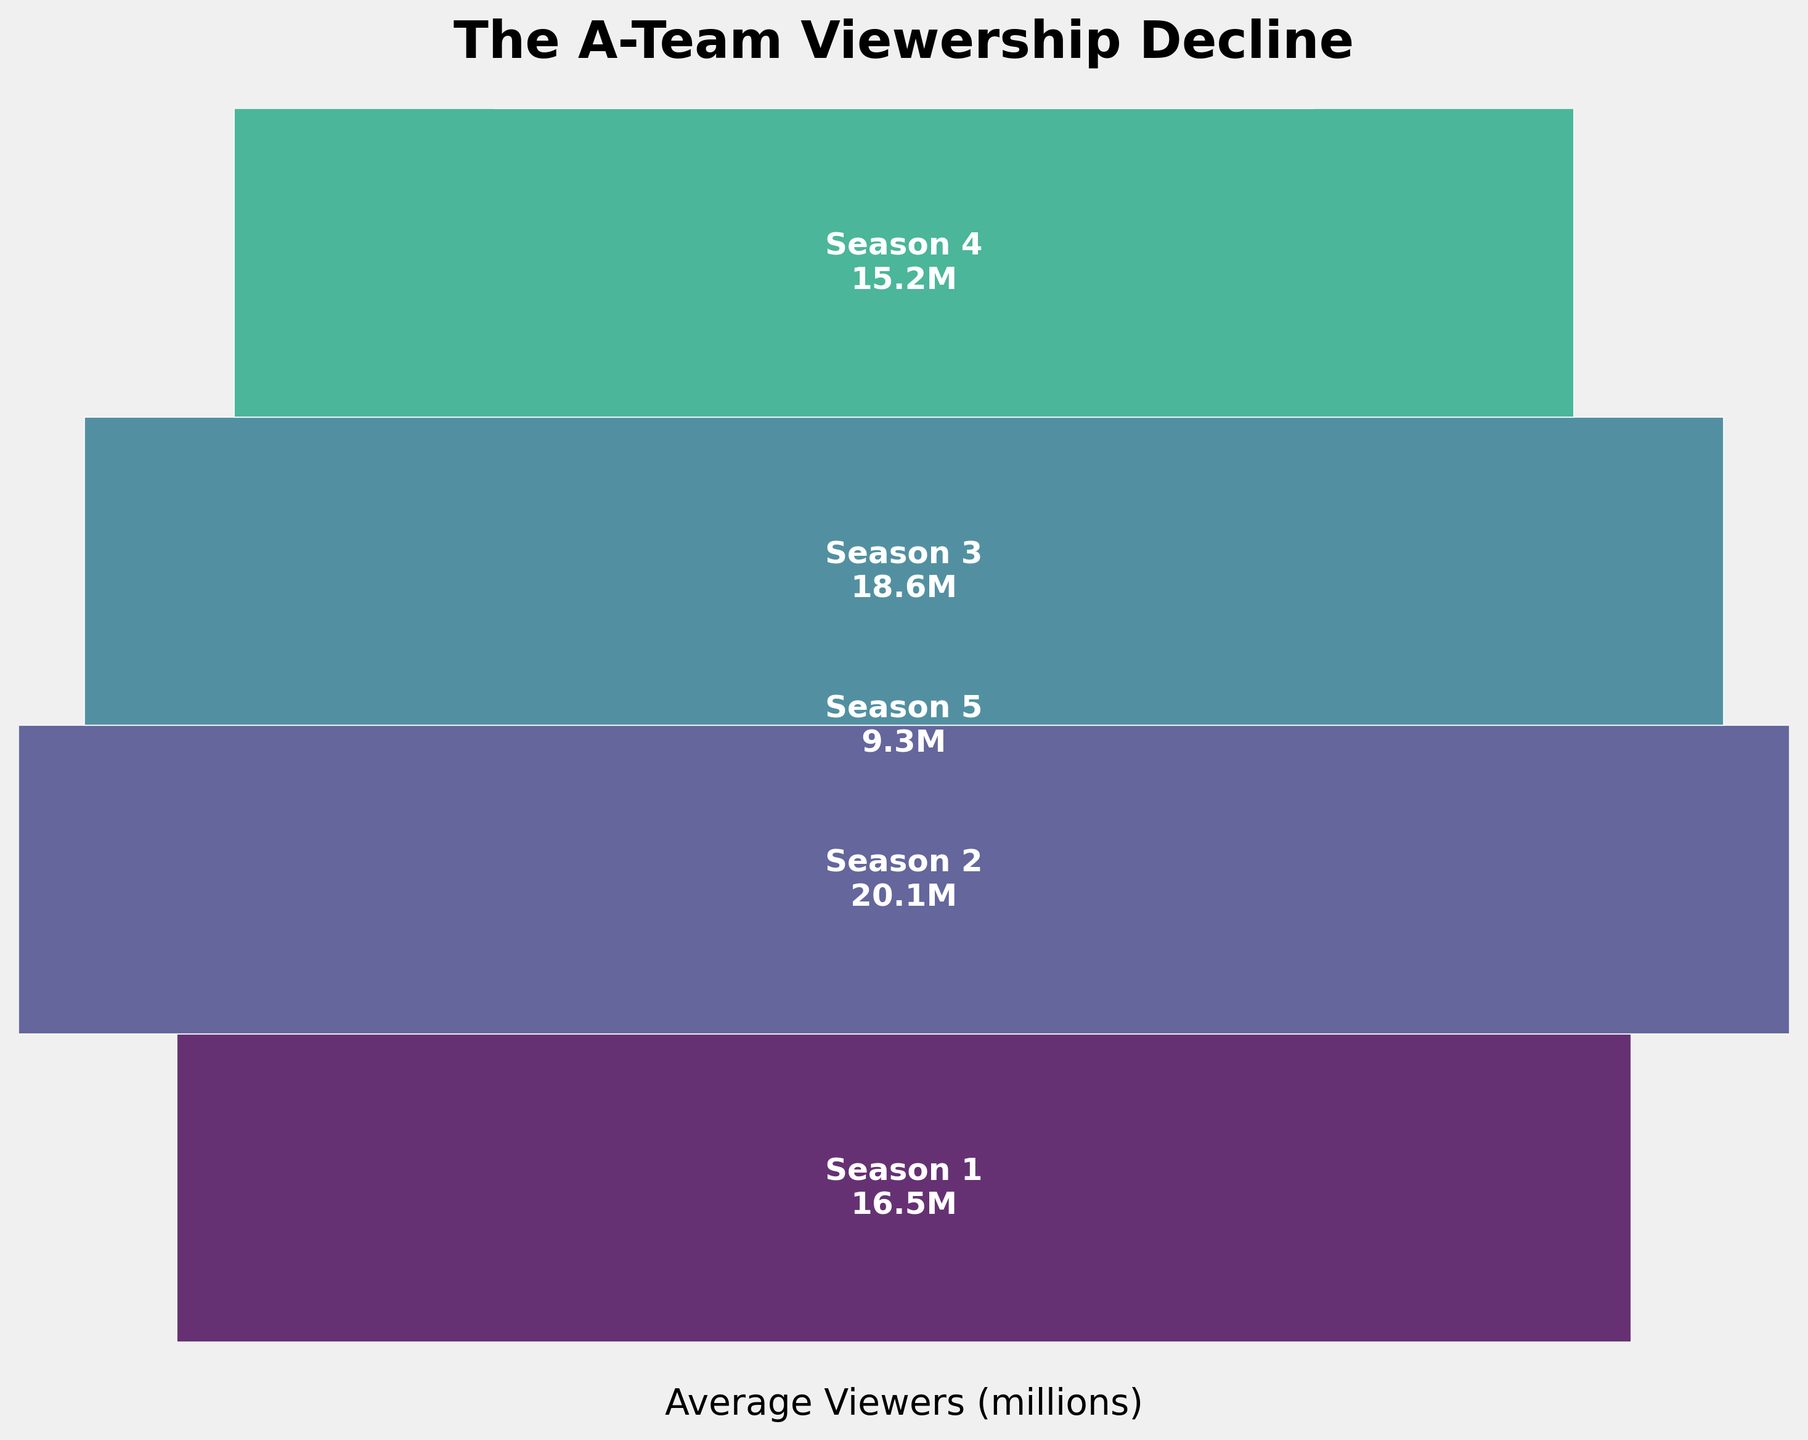What's the title of the chart? The title of the chart is usually displayed at the top of the figure to describe the data shown. In this figure, it states "The A-Team Viewership Decline".
Answer: The A-Team Viewership Decline How many distinct seasons are represented in the figure? Each section of the funnel represents a distinct season, and there are segments labeled from Season 1 to Season 5. Counting these gives us the total number of distinct seasons.
Answer: 5 Which season had the highest average viewership? By looking at the widest section of the funnel and noting the labeled average viewership, Season 2 is the widest segment indicating it had the highest average viewership at 20.1 million viewers.
Answer: Season 2 What is the average viewership for Season 4? Each segment of the funnel is labeled with the season and its average viewership. The label for Season 4 indicates that it had an average viewership of 15.2 million.
Answer: 15.2 million By how much did the viewership decline from Season 4 to Season 5? To find the decline, subtract the viewership of Season 5 from the viewership of Season 4: 15.2 million - 9.3 million.
Answer: 5.9 million What is the total decline in viewership from Season 1 to Season 5? Calculate the difference between the viewership in Season 1 and Season 5: 16.5 million - 9.3 million.
Answer: 7.2 million Which season shows the greatest decline in viewership compared to the previous season? By comparing the declines between consecutive seasons: 
Season 2 to Season 3: 20.1 - 18.6 = 1.5 million 
Season 3 to Season 4: 18.6 - 15.2 = 3.4 million 
Season 4 to Season 5: 15.2 - 9.3 = 5.9 million 
The greatest decline is from Season 4 to Season 5.
Answer: Season 4 to Season 5 How does the viewership in Season 3 compare to Season 1? By comparing the labeled viewership values for Season 3 and Season 1: Season 3 had 18.6 million viewers, while Season 1 had 16.5 million viewers. Season 3's viewership is higher than that of Season 1.
Answer: Higher What trend is observed in the viewership from Season 2 to Season 5? Observing the segments and their widths from Season 2 to Season 5 (i.e. 20.1M to 9.3M), there is a general decreasing trend in viewership.
Answer: Decreasing What is the average viewership over all five seasons? Sum the viewership of all seasons and divide by the number of seasons: 
(16.5 + 20.1 + 18.6 + 15.2 + 9.3) / 5 = 79.7 / 5.
Answer: 15.94 million 